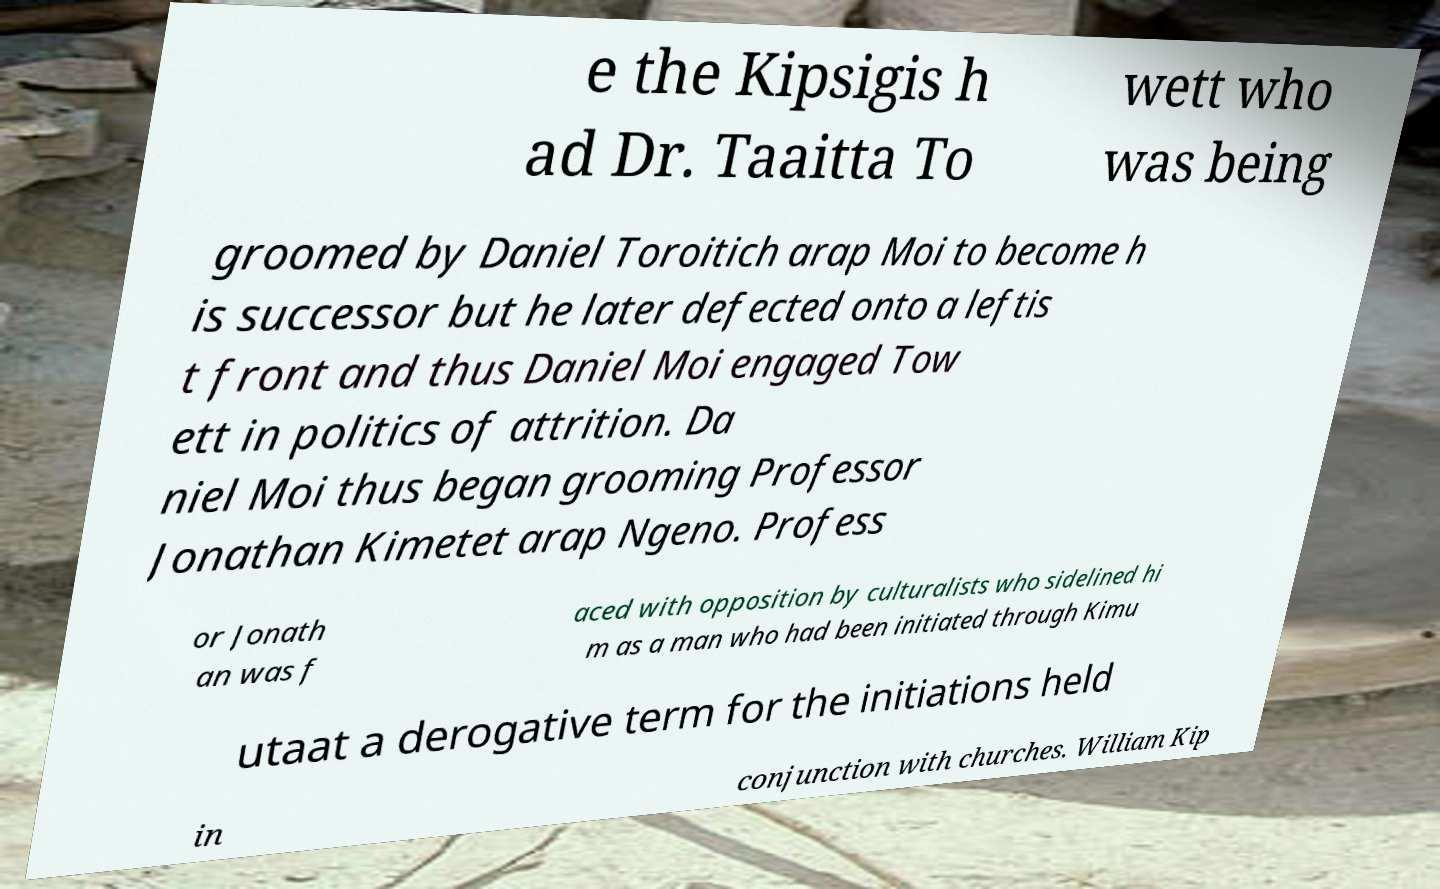Can you accurately transcribe the text from the provided image for me? e the Kipsigis h ad Dr. Taaitta To wett who was being groomed by Daniel Toroitich arap Moi to become h is successor but he later defected onto a leftis t front and thus Daniel Moi engaged Tow ett in politics of attrition. Da niel Moi thus began grooming Professor Jonathan Kimetet arap Ngeno. Profess or Jonath an was f aced with opposition by culturalists who sidelined hi m as a man who had been initiated through Kimu utaat a derogative term for the initiations held in conjunction with churches. William Kip 